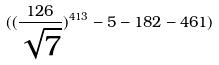Convert formula to latex. <formula><loc_0><loc_0><loc_500><loc_500>( ( \frac { 1 2 6 } { \sqrt { 7 } } ) ^ { 4 1 3 } - 5 - 1 8 2 - 4 6 1 )</formula> 